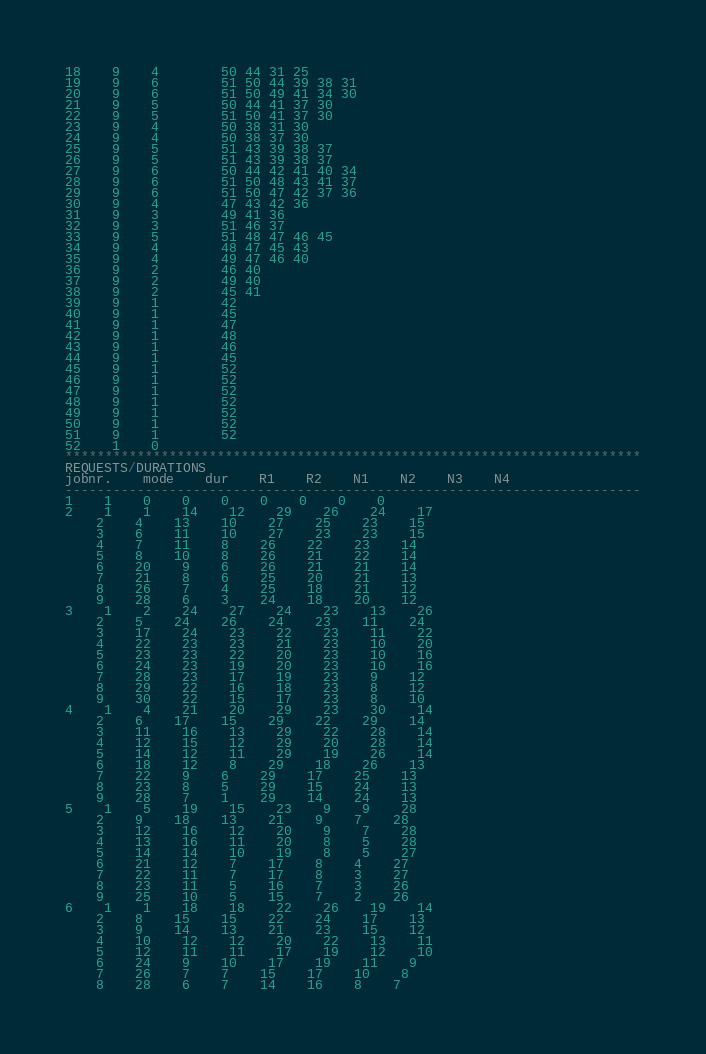<code> <loc_0><loc_0><loc_500><loc_500><_ObjectiveC_>18	9	4		50 44 31 25 
19	9	6		51 50 44 39 38 31 
20	9	6		51 50 49 41 34 30 
21	9	5		50 44 41 37 30 
22	9	5		51 50 41 37 30 
23	9	4		50 38 31 30 
24	9	4		50 38 37 30 
25	9	5		51 43 39 38 37 
26	9	5		51 43 39 38 37 
27	9	6		50 44 42 41 40 34 
28	9	6		51 50 48 43 41 37 
29	9	6		51 50 47 42 37 36 
30	9	4		47 43 42 36 
31	9	3		49 41 36 
32	9	3		51 46 37 
33	9	5		51 48 47 46 45 
34	9	4		48 47 45 43 
35	9	4		49 47 46 40 
36	9	2		46 40 
37	9	2		49 40 
38	9	2		45 41 
39	9	1		42 
40	9	1		45 
41	9	1		47 
42	9	1		48 
43	9	1		46 
44	9	1		45 
45	9	1		52 
46	9	1		52 
47	9	1		52 
48	9	1		52 
49	9	1		52 
50	9	1		52 
51	9	1		52 
52	1	0		
************************************************************************
REQUESTS/DURATIONS
jobnr.	mode	dur	R1	R2	N1	N2	N3	N4	
------------------------------------------------------------------------
1	1	0	0	0	0	0	0	0	
2	1	1	14	12	29	26	24	17	
	2	4	13	10	27	25	23	15	
	3	6	11	10	27	23	23	15	
	4	7	11	8	26	22	23	14	
	5	8	10	8	26	21	22	14	
	6	20	9	6	26	21	21	14	
	7	21	8	6	25	20	21	13	
	8	26	7	4	25	18	21	12	
	9	28	6	3	24	18	20	12	
3	1	2	24	27	24	23	13	26	
	2	5	24	26	24	23	11	24	
	3	17	24	23	22	23	11	22	
	4	22	23	23	21	23	10	20	
	5	23	23	22	20	23	10	16	
	6	24	23	19	20	23	10	16	
	7	28	23	17	19	23	9	12	
	8	29	22	16	18	23	8	12	
	9	30	22	15	17	23	8	10	
4	1	4	21	20	29	23	30	14	
	2	6	17	15	29	22	29	14	
	3	11	16	13	29	22	28	14	
	4	12	15	12	29	20	28	14	
	5	14	12	11	29	19	26	14	
	6	18	12	8	29	18	26	13	
	7	22	9	6	29	17	25	13	
	8	23	8	5	29	15	24	13	
	9	28	7	1	29	14	24	13	
5	1	5	19	15	23	9	9	28	
	2	9	18	13	21	9	7	28	
	3	12	16	12	20	9	7	28	
	4	13	16	11	20	8	5	28	
	5	14	14	10	19	8	5	27	
	6	21	12	7	17	8	4	27	
	7	22	11	7	17	8	3	27	
	8	23	11	5	16	7	3	26	
	9	25	10	5	15	7	2	26	
6	1	1	18	18	22	26	19	14	
	2	8	15	15	22	24	17	13	
	3	9	14	13	21	23	15	12	
	4	10	12	12	20	22	13	11	
	5	12	11	11	17	19	12	10	
	6	24	9	10	17	19	11	9	
	7	26	7	7	15	17	10	8	
	8	28	6	7	14	16	8	7	</code> 